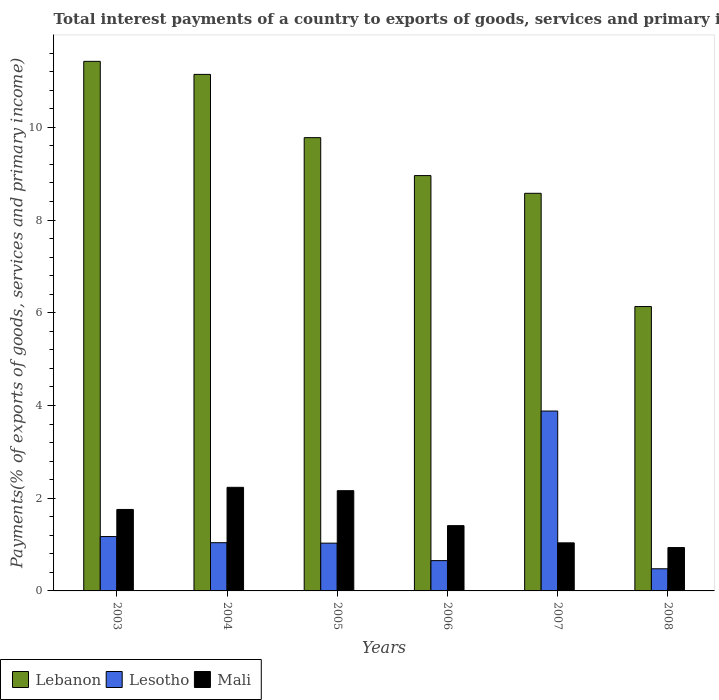How many different coloured bars are there?
Offer a terse response. 3. Are the number of bars per tick equal to the number of legend labels?
Ensure brevity in your answer.  Yes. What is the label of the 4th group of bars from the left?
Your answer should be compact. 2006. What is the total interest payments in Mali in 2006?
Keep it short and to the point. 1.41. Across all years, what is the maximum total interest payments in Lesotho?
Your response must be concise. 3.88. Across all years, what is the minimum total interest payments in Lesotho?
Provide a short and direct response. 0.48. In which year was the total interest payments in Lebanon maximum?
Provide a short and direct response. 2003. What is the total total interest payments in Mali in the graph?
Offer a very short reply. 9.53. What is the difference between the total interest payments in Lesotho in 2007 and that in 2008?
Provide a short and direct response. 3.4. What is the difference between the total interest payments in Lebanon in 2007 and the total interest payments in Mali in 2003?
Offer a very short reply. 6.82. What is the average total interest payments in Mali per year?
Offer a terse response. 1.59. In the year 2004, what is the difference between the total interest payments in Mali and total interest payments in Lesotho?
Ensure brevity in your answer.  1.19. What is the ratio of the total interest payments in Lesotho in 2003 to that in 2006?
Offer a terse response. 1.79. What is the difference between the highest and the second highest total interest payments in Lebanon?
Give a very brief answer. 0.28. What is the difference between the highest and the lowest total interest payments in Lebanon?
Ensure brevity in your answer.  5.29. What does the 2nd bar from the left in 2008 represents?
Give a very brief answer. Lesotho. What does the 3rd bar from the right in 2003 represents?
Your answer should be very brief. Lebanon. Is it the case that in every year, the sum of the total interest payments in Lebanon and total interest payments in Lesotho is greater than the total interest payments in Mali?
Give a very brief answer. Yes. How many years are there in the graph?
Your response must be concise. 6. What is the difference between two consecutive major ticks on the Y-axis?
Provide a short and direct response. 2. Does the graph contain any zero values?
Your answer should be compact. No. How many legend labels are there?
Your answer should be very brief. 3. What is the title of the graph?
Give a very brief answer. Total interest payments of a country to exports of goods, services and primary income. Does "Zambia" appear as one of the legend labels in the graph?
Provide a short and direct response. No. What is the label or title of the X-axis?
Offer a very short reply. Years. What is the label or title of the Y-axis?
Offer a terse response. Payments(% of exports of goods, services and primary income). What is the Payments(% of exports of goods, services and primary income) in Lebanon in 2003?
Ensure brevity in your answer.  11.42. What is the Payments(% of exports of goods, services and primary income) of Lesotho in 2003?
Your answer should be compact. 1.17. What is the Payments(% of exports of goods, services and primary income) in Mali in 2003?
Offer a terse response. 1.76. What is the Payments(% of exports of goods, services and primary income) in Lebanon in 2004?
Your response must be concise. 11.14. What is the Payments(% of exports of goods, services and primary income) of Lesotho in 2004?
Provide a short and direct response. 1.04. What is the Payments(% of exports of goods, services and primary income) of Mali in 2004?
Keep it short and to the point. 2.23. What is the Payments(% of exports of goods, services and primary income) of Lebanon in 2005?
Provide a short and direct response. 9.78. What is the Payments(% of exports of goods, services and primary income) in Lesotho in 2005?
Your answer should be very brief. 1.03. What is the Payments(% of exports of goods, services and primary income) of Mali in 2005?
Provide a succinct answer. 2.16. What is the Payments(% of exports of goods, services and primary income) in Lebanon in 2006?
Provide a short and direct response. 8.96. What is the Payments(% of exports of goods, services and primary income) in Lesotho in 2006?
Give a very brief answer. 0.65. What is the Payments(% of exports of goods, services and primary income) of Mali in 2006?
Your response must be concise. 1.41. What is the Payments(% of exports of goods, services and primary income) in Lebanon in 2007?
Offer a terse response. 8.58. What is the Payments(% of exports of goods, services and primary income) in Lesotho in 2007?
Provide a succinct answer. 3.88. What is the Payments(% of exports of goods, services and primary income) of Mali in 2007?
Ensure brevity in your answer.  1.04. What is the Payments(% of exports of goods, services and primary income) in Lebanon in 2008?
Your answer should be very brief. 6.13. What is the Payments(% of exports of goods, services and primary income) in Lesotho in 2008?
Keep it short and to the point. 0.48. What is the Payments(% of exports of goods, services and primary income) of Mali in 2008?
Keep it short and to the point. 0.94. Across all years, what is the maximum Payments(% of exports of goods, services and primary income) in Lebanon?
Ensure brevity in your answer.  11.42. Across all years, what is the maximum Payments(% of exports of goods, services and primary income) of Lesotho?
Give a very brief answer. 3.88. Across all years, what is the maximum Payments(% of exports of goods, services and primary income) in Mali?
Provide a succinct answer. 2.23. Across all years, what is the minimum Payments(% of exports of goods, services and primary income) in Lebanon?
Ensure brevity in your answer.  6.13. Across all years, what is the minimum Payments(% of exports of goods, services and primary income) of Lesotho?
Keep it short and to the point. 0.48. Across all years, what is the minimum Payments(% of exports of goods, services and primary income) of Mali?
Your answer should be compact. 0.94. What is the total Payments(% of exports of goods, services and primary income) in Lebanon in the graph?
Provide a short and direct response. 56.01. What is the total Payments(% of exports of goods, services and primary income) in Lesotho in the graph?
Ensure brevity in your answer.  8.25. What is the total Payments(% of exports of goods, services and primary income) in Mali in the graph?
Offer a terse response. 9.53. What is the difference between the Payments(% of exports of goods, services and primary income) of Lebanon in 2003 and that in 2004?
Provide a short and direct response. 0.28. What is the difference between the Payments(% of exports of goods, services and primary income) in Lesotho in 2003 and that in 2004?
Keep it short and to the point. 0.13. What is the difference between the Payments(% of exports of goods, services and primary income) in Mali in 2003 and that in 2004?
Offer a terse response. -0.48. What is the difference between the Payments(% of exports of goods, services and primary income) in Lebanon in 2003 and that in 2005?
Provide a short and direct response. 1.65. What is the difference between the Payments(% of exports of goods, services and primary income) in Lesotho in 2003 and that in 2005?
Offer a very short reply. 0.14. What is the difference between the Payments(% of exports of goods, services and primary income) of Mali in 2003 and that in 2005?
Offer a terse response. -0.41. What is the difference between the Payments(% of exports of goods, services and primary income) in Lebanon in 2003 and that in 2006?
Keep it short and to the point. 2.46. What is the difference between the Payments(% of exports of goods, services and primary income) of Lesotho in 2003 and that in 2006?
Provide a succinct answer. 0.52. What is the difference between the Payments(% of exports of goods, services and primary income) of Mali in 2003 and that in 2006?
Give a very brief answer. 0.35. What is the difference between the Payments(% of exports of goods, services and primary income) in Lebanon in 2003 and that in 2007?
Provide a short and direct response. 2.85. What is the difference between the Payments(% of exports of goods, services and primary income) in Lesotho in 2003 and that in 2007?
Make the answer very short. -2.71. What is the difference between the Payments(% of exports of goods, services and primary income) of Mali in 2003 and that in 2007?
Your answer should be very brief. 0.72. What is the difference between the Payments(% of exports of goods, services and primary income) of Lebanon in 2003 and that in 2008?
Make the answer very short. 5.29. What is the difference between the Payments(% of exports of goods, services and primary income) in Lesotho in 2003 and that in 2008?
Your answer should be very brief. 0.69. What is the difference between the Payments(% of exports of goods, services and primary income) of Mali in 2003 and that in 2008?
Keep it short and to the point. 0.82. What is the difference between the Payments(% of exports of goods, services and primary income) in Lebanon in 2004 and that in 2005?
Provide a short and direct response. 1.36. What is the difference between the Payments(% of exports of goods, services and primary income) of Lesotho in 2004 and that in 2005?
Make the answer very short. 0.01. What is the difference between the Payments(% of exports of goods, services and primary income) of Mali in 2004 and that in 2005?
Provide a short and direct response. 0.07. What is the difference between the Payments(% of exports of goods, services and primary income) in Lebanon in 2004 and that in 2006?
Your response must be concise. 2.18. What is the difference between the Payments(% of exports of goods, services and primary income) of Lesotho in 2004 and that in 2006?
Provide a succinct answer. 0.39. What is the difference between the Payments(% of exports of goods, services and primary income) in Mali in 2004 and that in 2006?
Offer a very short reply. 0.83. What is the difference between the Payments(% of exports of goods, services and primary income) in Lebanon in 2004 and that in 2007?
Offer a terse response. 2.56. What is the difference between the Payments(% of exports of goods, services and primary income) of Lesotho in 2004 and that in 2007?
Provide a short and direct response. -2.84. What is the difference between the Payments(% of exports of goods, services and primary income) of Mali in 2004 and that in 2007?
Give a very brief answer. 1.2. What is the difference between the Payments(% of exports of goods, services and primary income) in Lebanon in 2004 and that in 2008?
Your answer should be compact. 5.01. What is the difference between the Payments(% of exports of goods, services and primary income) of Lesotho in 2004 and that in 2008?
Your answer should be compact. 0.56. What is the difference between the Payments(% of exports of goods, services and primary income) in Mali in 2004 and that in 2008?
Provide a short and direct response. 1.3. What is the difference between the Payments(% of exports of goods, services and primary income) of Lebanon in 2005 and that in 2006?
Your answer should be compact. 0.82. What is the difference between the Payments(% of exports of goods, services and primary income) of Lesotho in 2005 and that in 2006?
Give a very brief answer. 0.38. What is the difference between the Payments(% of exports of goods, services and primary income) of Mali in 2005 and that in 2006?
Your response must be concise. 0.75. What is the difference between the Payments(% of exports of goods, services and primary income) in Lebanon in 2005 and that in 2007?
Ensure brevity in your answer.  1.2. What is the difference between the Payments(% of exports of goods, services and primary income) in Lesotho in 2005 and that in 2007?
Provide a succinct answer. -2.85. What is the difference between the Payments(% of exports of goods, services and primary income) of Mali in 2005 and that in 2007?
Give a very brief answer. 1.13. What is the difference between the Payments(% of exports of goods, services and primary income) of Lebanon in 2005 and that in 2008?
Keep it short and to the point. 3.64. What is the difference between the Payments(% of exports of goods, services and primary income) of Lesotho in 2005 and that in 2008?
Provide a succinct answer. 0.55. What is the difference between the Payments(% of exports of goods, services and primary income) of Mali in 2005 and that in 2008?
Give a very brief answer. 1.23. What is the difference between the Payments(% of exports of goods, services and primary income) in Lebanon in 2006 and that in 2007?
Keep it short and to the point. 0.38. What is the difference between the Payments(% of exports of goods, services and primary income) of Lesotho in 2006 and that in 2007?
Provide a short and direct response. -3.23. What is the difference between the Payments(% of exports of goods, services and primary income) of Mali in 2006 and that in 2007?
Make the answer very short. 0.37. What is the difference between the Payments(% of exports of goods, services and primary income) in Lebanon in 2006 and that in 2008?
Provide a short and direct response. 2.82. What is the difference between the Payments(% of exports of goods, services and primary income) in Lesotho in 2006 and that in 2008?
Provide a succinct answer. 0.18. What is the difference between the Payments(% of exports of goods, services and primary income) of Mali in 2006 and that in 2008?
Your answer should be compact. 0.47. What is the difference between the Payments(% of exports of goods, services and primary income) of Lebanon in 2007 and that in 2008?
Offer a terse response. 2.44. What is the difference between the Payments(% of exports of goods, services and primary income) of Lesotho in 2007 and that in 2008?
Your answer should be compact. 3.4. What is the difference between the Payments(% of exports of goods, services and primary income) of Mali in 2007 and that in 2008?
Your response must be concise. 0.1. What is the difference between the Payments(% of exports of goods, services and primary income) in Lebanon in 2003 and the Payments(% of exports of goods, services and primary income) in Lesotho in 2004?
Provide a short and direct response. 10.38. What is the difference between the Payments(% of exports of goods, services and primary income) of Lebanon in 2003 and the Payments(% of exports of goods, services and primary income) of Mali in 2004?
Ensure brevity in your answer.  9.19. What is the difference between the Payments(% of exports of goods, services and primary income) in Lesotho in 2003 and the Payments(% of exports of goods, services and primary income) in Mali in 2004?
Your answer should be very brief. -1.06. What is the difference between the Payments(% of exports of goods, services and primary income) of Lebanon in 2003 and the Payments(% of exports of goods, services and primary income) of Lesotho in 2005?
Your response must be concise. 10.39. What is the difference between the Payments(% of exports of goods, services and primary income) of Lebanon in 2003 and the Payments(% of exports of goods, services and primary income) of Mali in 2005?
Provide a succinct answer. 9.26. What is the difference between the Payments(% of exports of goods, services and primary income) of Lesotho in 2003 and the Payments(% of exports of goods, services and primary income) of Mali in 2005?
Make the answer very short. -0.99. What is the difference between the Payments(% of exports of goods, services and primary income) of Lebanon in 2003 and the Payments(% of exports of goods, services and primary income) of Lesotho in 2006?
Provide a succinct answer. 10.77. What is the difference between the Payments(% of exports of goods, services and primary income) in Lebanon in 2003 and the Payments(% of exports of goods, services and primary income) in Mali in 2006?
Offer a terse response. 10.01. What is the difference between the Payments(% of exports of goods, services and primary income) in Lesotho in 2003 and the Payments(% of exports of goods, services and primary income) in Mali in 2006?
Keep it short and to the point. -0.24. What is the difference between the Payments(% of exports of goods, services and primary income) of Lebanon in 2003 and the Payments(% of exports of goods, services and primary income) of Lesotho in 2007?
Offer a terse response. 7.54. What is the difference between the Payments(% of exports of goods, services and primary income) in Lebanon in 2003 and the Payments(% of exports of goods, services and primary income) in Mali in 2007?
Provide a succinct answer. 10.39. What is the difference between the Payments(% of exports of goods, services and primary income) in Lesotho in 2003 and the Payments(% of exports of goods, services and primary income) in Mali in 2007?
Ensure brevity in your answer.  0.14. What is the difference between the Payments(% of exports of goods, services and primary income) in Lebanon in 2003 and the Payments(% of exports of goods, services and primary income) in Lesotho in 2008?
Your answer should be very brief. 10.94. What is the difference between the Payments(% of exports of goods, services and primary income) of Lebanon in 2003 and the Payments(% of exports of goods, services and primary income) of Mali in 2008?
Your response must be concise. 10.49. What is the difference between the Payments(% of exports of goods, services and primary income) of Lesotho in 2003 and the Payments(% of exports of goods, services and primary income) of Mali in 2008?
Your answer should be compact. 0.24. What is the difference between the Payments(% of exports of goods, services and primary income) in Lebanon in 2004 and the Payments(% of exports of goods, services and primary income) in Lesotho in 2005?
Keep it short and to the point. 10.11. What is the difference between the Payments(% of exports of goods, services and primary income) of Lebanon in 2004 and the Payments(% of exports of goods, services and primary income) of Mali in 2005?
Your answer should be compact. 8.98. What is the difference between the Payments(% of exports of goods, services and primary income) of Lesotho in 2004 and the Payments(% of exports of goods, services and primary income) of Mali in 2005?
Ensure brevity in your answer.  -1.12. What is the difference between the Payments(% of exports of goods, services and primary income) in Lebanon in 2004 and the Payments(% of exports of goods, services and primary income) in Lesotho in 2006?
Your answer should be compact. 10.49. What is the difference between the Payments(% of exports of goods, services and primary income) in Lebanon in 2004 and the Payments(% of exports of goods, services and primary income) in Mali in 2006?
Offer a very short reply. 9.73. What is the difference between the Payments(% of exports of goods, services and primary income) in Lesotho in 2004 and the Payments(% of exports of goods, services and primary income) in Mali in 2006?
Ensure brevity in your answer.  -0.37. What is the difference between the Payments(% of exports of goods, services and primary income) in Lebanon in 2004 and the Payments(% of exports of goods, services and primary income) in Lesotho in 2007?
Keep it short and to the point. 7.26. What is the difference between the Payments(% of exports of goods, services and primary income) of Lebanon in 2004 and the Payments(% of exports of goods, services and primary income) of Mali in 2007?
Give a very brief answer. 10.1. What is the difference between the Payments(% of exports of goods, services and primary income) in Lesotho in 2004 and the Payments(% of exports of goods, services and primary income) in Mali in 2007?
Ensure brevity in your answer.  0. What is the difference between the Payments(% of exports of goods, services and primary income) in Lebanon in 2004 and the Payments(% of exports of goods, services and primary income) in Lesotho in 2008?
Offer a very short reply. 10.66. What is the difference between the Payments(% of exports of goods, services and primary income) in Lebanon in 2004 and the Payments(% of exports of goods, services and primary income) in Mali in 2008?
Provide a succinct answer. 10.21. What is the difference between the Payments(% of exports of goods, services and primary income) of Lesotho in 2004 and the Payments(% of exports of goods, services and primary income) of Mali in 2008?
Your answer should be very brief. 0.1. What is the difference between the Payments(% of exports of goods, services and primary income) in Lebanon in 2005 and the Payments(% of exports of goods, services and primary income) in Lesotho in 2006?
Your response must be concise. 9.12. What is the difference between the Payments(% of exports of goods, services and primary income) in Lebanon in 2005 and the Payments(% of exports of goods, services and primary income) in Mali in 2006?
Provide a short and direct response. 8.37. What is the difference between the Payments(% of exports of goods, services and primary income) in Lesotho in 2005 and the Payments(% of exports of goods, services and primary income) in Mali in 2006?
Your response must be concise. -0.38. What is the difference between the Payments(% of exports of goods, services and primary income) of Lebanon in 2005 and the Payments(% of exports of goods, services and primary income) of Lesotho in 2007?
Provide a short and direct response. 5.9. What is the difference between the Payments(% of exports of goods, services and primary income) of Lebanon in 2005 and the Payments(% of exports of goods, services and primary income) of Mali in 2007?
Offer a terse response. 8.74. What is the difference between the Payments(% of exports of goods, services and primary income) in Lesotho in 2005 and the Payments(% of exports of goods, services and primary income) in Mali in 2007?
Give a very brief answer. -0.01. What is the difference between the Payments(% of exports of goods, services and primary income) of Lebanon in 2005 and the Payments(% of exports of goods, services and primary income) of Lesotho in 2008?
Offer a terse response. 9.3. What is the difference between the Payments(% of exports of goods, services and primary income) of Lebanon in 2005 and the Payments(% of exports of goods, services and primary income) of Mali in 2008?
Keep it short and to the point. 8.84. What is the difference between the Payments(% of exports of goods, services and primary income) in Lesotho in 2005 and the Payments(% of exports of goods, services and primary income) in Mali in 2008?
Give a very brief answer. 0.1. What is the difference between the Payments(% of exports of goods, services and primary income) of Lebanon in 2006 and the Payments(% of exports of goods, services and primary income) of Lesotho in 2007?
Provide a short and direct response. 5.08. What is the difference between the Payments(% of exports of goods, services and primary income) in Lebanon in 2006 and the Payments(% of exports of goods, services and primary income) in Mali in 2007?
Your answer should be compact. 7.92. What is the difference between the Payments(% of exports of goods, services and primary income) of Lesotho in 2006 and the Payments(% of exports of goods, services and primary income) of Mali in 2007?
Offer a very short reply. -0.38. What is the difference between the Payments(% of exports of goods, services and primary income) of Lebanon in 2006 and the Payments(% of exports of goods, services and primary income) of Lesotho in 2008?
Give a very brief answer. 8.48. What is the difference between the Payments(% of exports of goods, services and primary income) of Lebanon in 2006 and the Payments(% of exports of goods, services and primary income) of Mali in 2008?
Offer a very short reply. 8.02. What is the difference between the Payments(% of exports of goods, services and primary income) in Lesotho in 2006 and the Payments(% of exports of goods, services and primary income) in Mali in 2008?
Your answer should be compact. -0.28. What is the difference between the Payments(% of exports of goods, services and primary income) of Lebanon in 2007 and the Payments(% of exports of goods, services and primary income) of Lesotho in 2008?
Ensure brevity in your answer.  8.1. What is the difference between the Payments(% of exports of goods, services and primary income) in Lebanon in 2007 and the Payments(% of exports of goods, services and primary income) in Mali in 2008?
Ensure brevity in your answer.  7.64. What is the difference between the Payments(% of exports of goods, services and primary income) of Lesotho in 2007 and the Payments(% of exports of goods, services and primary income) of Mali in 2008?
Give a very brief answer. 2.94. What is the average Payments(% of exports of goods, services and primary income) in Lebanon per year?
Make the answer very short. 9.33. What is the average Payments(% of exports of goods, services and primary income) in Lesotho per year?
Offer a terse response. 1.38. What is the average Payments(% of exports of goods, services and primary income) in Mali per year?
Give a very brief answer. 1.59. In the year 2003, what is the difference between the Payments(% of exports of goods, services and primary income) in Lebanon and Payments(% of exports of goods, services and primary income) in Lesotho?
Your answer should be compact. 10.25. In the year 2003, what is the difference between the Payments(% of exports of goods, services and primary income) in Lebanon and Payments(% of exports of goods, services and primary income) in Mali?
Give a very brief answer. 9.66. In the year 2003, what is the difference between the Payments(% of exports of goods, services and primary income) of Lesotho and Payments(% of exports of goods, services and primary income) of Mali?
Make the answer very short. -0.58. In the year 2004, what is the difference between the Payments(% of exports of goods, services and primary income) of Lebanon and Payments(% of exports of goods, services and primary income) of Lesotho?
Your answer should be compact. 10.1. In the year 2004, what is the difference between the Payments(% of exports of goods, services and primary income) in Lebanon and Payments(% of exports of goods, services and primary income) in Mali?
Offer a terse response. 8.91. In the year 2004, what is the difference between the Payments(% of exports of goods, services and primary income) of Lesotho and Payments(% of exports of goods, services and primary income) of Mali?
Ensure brevity in your answer.  -1.19. In the year 2005, what is the difference between the Payments(% of exports of goods, services and primary income) in Lebanon and Payments(% of exports of goods, services and primary income) in Lesotho?
Your response must be concise. 8.75. In the year 2005, what is the difference between the Payments(% of exports of goods, services and primary income) of Lebanon and Payments(% of exports of goods, services and primary income) of Mali?
Your answer should be compact. 7.61. In the year 2005, what is the difference between the Payments(% of exports of goods, services and primary income) of Lesotho and Payments(% of exports of goods, services and primary income) of Mali?
Keep it short and to the point. -1.13. In the year 2006, what is the difference between the Payments(% of exports of goods, services and primary income) in Lebanon and Payments(% of exports of goods, services and primary income) in Lesotho?
Ensure brevity in your answer.  8.3. In the year 2006, what is the difference between the Payments(% of exports of goods, services and primary income) in Lebanon and Payments(% of exports of goods, services and primary income) in Mali?
Provide a short and direct response. 7.55. In the year 2006, what is the difference between the Payments(% of exports of goods, services and primary income) in Lesotho and Payments(% of exports of goods, services and primary income) in Mali?
Ensure brevity in your answer.  -0.75. In the year 2007, what is the difference between the Payments(% of exports of goods, services and primary income) of Lebanon and Payments(% of exports of goods, services and primary income) of Lesotho?
Provide a short and direct response. 4.7. In the year 2007, what is the difference between the Payments(% of exports of goods, services and primary income) in Lebanon and Payments(% of exports of goods, services and primary income) in Mali?
Your answer should be very brief. 7.54. In the year 2007, what is the difference between the Payments(% of exports of goods, services and primary income) in Lesotho and Payments(% of exports of goods, services and primary income) in Mali?
Offer a terse response. 2.84. In the year 2008, what is the difference between the Payments(% of exports of goods, services and primary income) in Lebanon and Payments(% of exports of goods, services and primary income) in Lesotho?
Provide a succinct answer. 5.66. In the year 2008, what is the difference between the Payments(% of exports of goods, services and primary income) in Lebanon and Payments(% of exports of goods, services and primary income) in Mali?
Your answer should be compact. 5.2. In the year 2008, what is the difference between the Payments(% of exports of goods, services and primary income) of Lesotho and Payments(% of exports of goods, services and primary income) of Mali?
Offer a very short reply. -0.46. What is the ratio of the Payments(% of exports of goods, services and primary income) in Lebanon in 2003 to that in 2004?
Keep it short and to the point. 1.03. What is the ratio of the Payments(% of exports of goods, services and primary income) of Lesotho in 2003 to that in 2004?
Keep it short and to the point. 1.13. What is the ratio of the Payments(% of exports of goods, services and primary income) in Mali in 2003 to that in 2004?
Your answer should be very brief. 0.79. What is the ratio of the Payments(% of exports of goods, services and primary income) in Lebanon in 2003 to that in 2005?
Your answer should be very brief. 1.17. What is the ratio of the Payments(% of exports of goods, services and primary income) in Lesotho in 2003 to that in 2005?
Your answer should be compact. 1.14. What is the ratio of the Payments(% of exports of goods, services and primary income) in Mali in 2003 to that in 2005?
Keep it short and to the point. 0.81. What is the ratio of the Payments(% of exports of goods, services and primary income) in Lebanon in 2003 to that in 2006?
Your answer should be compact. 1.27. What is the ratio of the Payments(% of exports of goods, services and primary income) in Lesotho in 2003 to that in 2006?
Your answer should be very brief. 1.79. What is the ratio of the Payments(% of exports of goods, services and primary income) in Mali in 2003 to that in 2006?
Offer a very short reply. 1.25. What is the ratio of the Payments(% of exports of goods, services and primary income) of Lebanon in 2003 to that in 2007?
Keep it short and to the point. 1.33. What is the ratio of the Payments(% of exports of goods, services and primary income) in Lesotho in 2003 to that in 2007?
Offer a very short reply. 0.3. What is the ratio of the Payments(% of exports of goods, services and primary income) of Mali in 2003 to that in 2007?
Make the answer very short. 1.69. What is the ratio of the Payments(% of exports of goods, services and primary income) of Lebanon in 2003 to that in 2008?
Give a very brief answer. 1.86. What is the ratio of the Payments(% of exports of goods, services and primary income) in Lesotho in 2003 to that in 2008?
Ensure brevity in your answer.  2.45. What is the ratio of the Payments(% of exports of goods, services and primary income) of Mali in 2003 to that in 2008?
Give a very brief answer. 1.88. What is the ratio of the Payments(% of exports of goods, services and primary income) in Lebanon in 2004 to that in 2005?
Offer a terse response. 1.14. What is the ratio of the Payments(% of exports of goods, services and primary income) of Lesotho in 2004 to that in 2005?
Offer a terse response. 1.01. What is the ratio of the Payments(% of exports of goods, services and primary income) of Mali in 2004 to that in 2005?
Keep it short and to the point. 1.03. What is the ratio of the Payments(% of exports of goods, services and primary income) of Lebanon in 2004 to that in 2006?
Offer a very short reply. 1.24. What is the ratio of the Payments(% of exports of goods, services and primary income) of Lesotho in 2004 to that in 2006?
Make the answer very short. 1.59. What is the ratio of the Payments(% of exports of goods, services and primary income) in Mali in 2004 to that in 2006?
Offer a very short reply. 1.59. What is the ratio of the Payments(% of exports of goods, services and primary income) in Lebanon in 2004 to that in 2007?
Your answer should be compact. 1.3. What is the ratio of the Payments(% of exports of goods, services and primary income) of Lesotho in 2004 to that in 2007?
Your response must be concise. 0.27. What is the ratio of the Payments(% of exports of goods, services and primary income) of Mali in 2004 to that in 2007?
Ensure brevity in your answer.  2.16. What is the ratio of the Payments(% of exports of goods, services and primary income) in Lebanon in 2004 to that in 2008?
Give a very brief answer. 1.82. What is the ratio of the Payments(% of exports of goods, services and primary income) of Lesotho in 2004 to that in 2008?
Give a very brief answer. 2.18. What is the ratio of the Payments(% of exports of goods, services and primary income) in Mali in 2004 to that in 2008?
Make the answer very short. 2.39. What is the ratio of the Payments(% of exports of goods, services and primary income) in Lebanon in 2005 to that in 2006?
Your answer should be compact. 1.09. What is the ratio of the Payments(% of exports of goods, services and primary income) in Lesotho in 2005 to that in 2006?
Offer a terse response. 1.58. What is the ratio of the Payments(% of exports of goods, services and primary income) of Mali in 2005 to that in 2006?
Offer a very short reply. 1.54. What is the ratio of the Payments(% of exports of goods, services and primary income) of Lebanon in 2005 to that in 2007?
Ensure brevity in your answer.  1.14. What is the ratio of the Payments(% of exports of goods, services and primary income) of Lesotho in 2005 to that in 2007?
Provide a succinct answer. 0.27. What is the ratio of the Payments(% of exports of goods, services and primary income) of Mali in 2005 to that in 2007?
Provide a short and direct response. 2.09. What is the ratio of the Payments(% of exports of goods, services and primary income) of Lebanon in 2005 to that in 2008?
Ensure brevity in your answer.  1.59. What is the ratio of the Payments(% of exports of goods, services and primary income) in Lesotho in 2005 to that in 2008?
Your answer should be compact. 2.16. What is the ratio of the Payments(% of exports of goods, services and primary income) of Mali in 2005 to that in 2008?
Keep it short and to the point. 2.31. What is the ratio of the Payments(% of exports of goods, services and primary income) of Lebanon in 2006 to that in 2007?
Your answer should be compact. 1.04. What is the ratio of the Payments(% of exports of goods, services and primary income) in Lesotho in 2006 to that in 2007?
Keep it short and to the point. 0.17. What is the ratio of the Payments(% of exports of goods, services and primary income) in Mali in 2006 to that in 2007?
Provide a short and direct response. 1.36. What is the ratio of the Payments(% of exports of goods, services and primary income) of Lebanon in 2006 to that in 2008?
Your answer should be very brief. 1.46. What is the ratio of the Payments(% of exports of goods, services and primary income) of Lesotho in 2006 to that in 2008?
Make the answer very short. 1.37. What is the ratio of the Payments(% of exports of goods, services and primary income) of Mali in 2006 to that in 2008?
Your answer should be very brief. 1.51. What is the ratio of the Payments(% of exports of goods, services and primary income) in Lebanon in 2007 to that in 2008?
Offer a terse response. 1.4. What is the ratio of the Payments(% of exports of goods, services and primary income) in Lesotho in 2007 to that in 2008?
Your answer should be compact. 8.12. What is the ratio of the Payments(% of exports of goods, services and primary income) in Mali in 2007 to that in 2008?
Your answer should be very brief. 1.11. What is the difference between the highest and the second highest Payments(% of exports of goods, services and primary income) in Lebanon?
Give a very brief answer. 0.28. What is the difference between the highest and the second highest Payments(% of exports of goods, services and primary income) of Lesotho?
Give a very brief answer. 2.71. What is the difference between the highest and the second highest Payments(% of exports of goods, services and primary income) of Mali?
Keep it short and to the point. 0.07. What is the difference between the highest and the lowest Payments(% of exports of goods, services and primary income) in Lebanon?
Provide a succinct answer. 5.29. What is the difference between the highest and the lowest Payments(% of exports of goods, services and primary income) in Lesotho?
Keep it short and to the point. 3.4. What is the difference between the highest and the lowest Payments(% of exports of goods, services and primary income) of Mali?
Give a very brief answer. 1.3. 